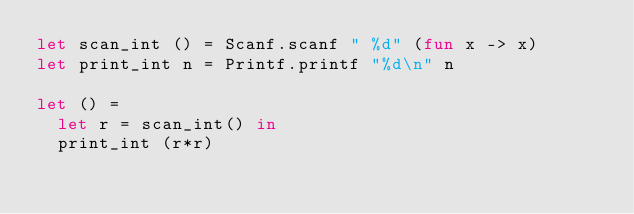Convert code to text. <code><loc_0><loc_0><loc_500><loc_500><_OCaml_>let scan_int () = Scanf.scanf " %d" (fun x -> x)
let print_int n = Printf.printf "%d\n" n

let () =
  let r = scan_int() in
  print_int (r*r)</code> 